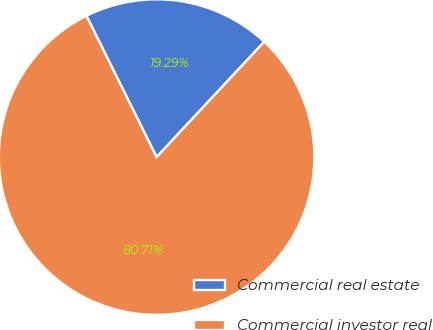Convert chart. <chart><loc_0><loc_0><loc_500><loc_500><pie_chart><fcel>Commercial real estate<fcel>Commercial investor real<nl><fcel>19.29%<fcel>80.71%<nl></chart> 